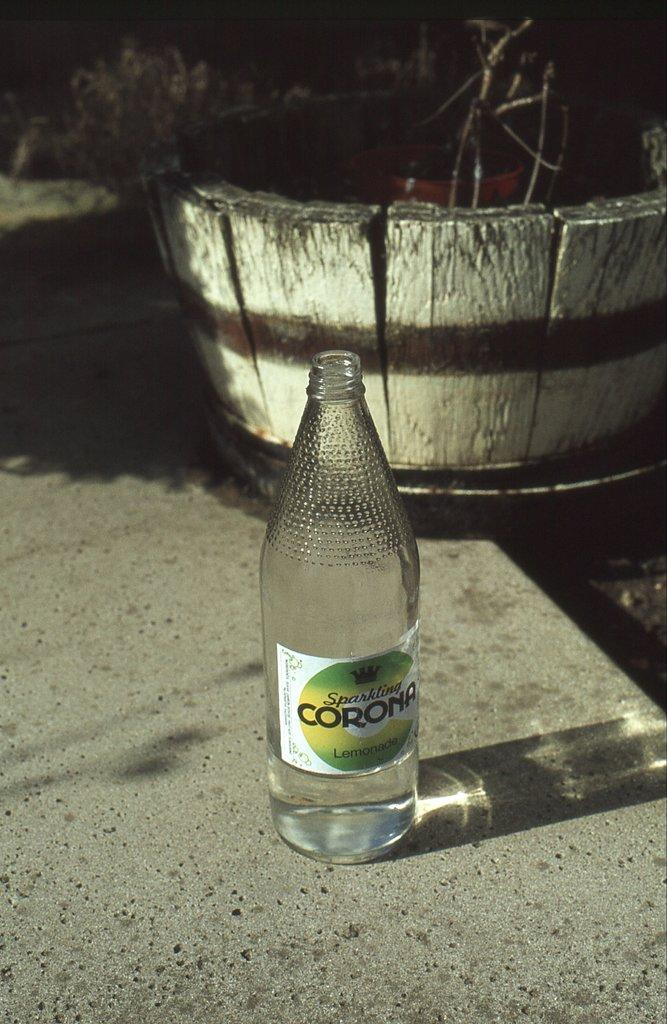<image>
Relay a brief, clear account of the picture shown. Sparkling corona Lemonade is sitting on a step near a barrel planter 